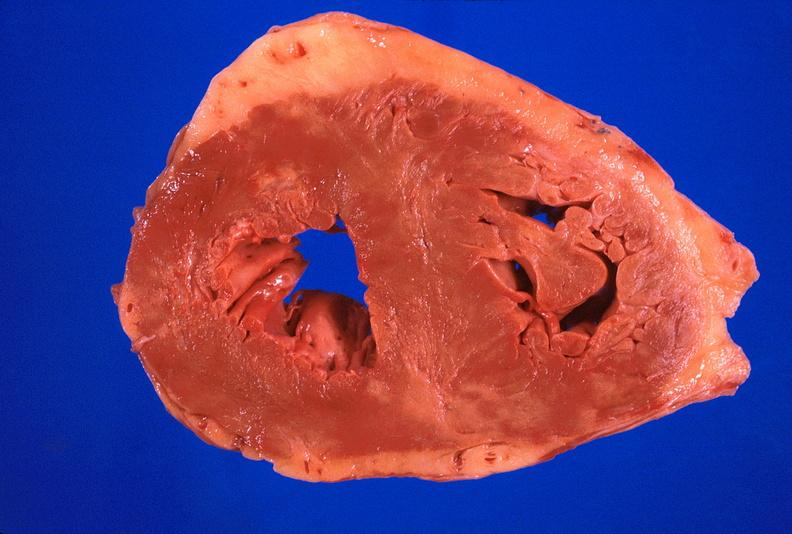where is this?
Answer the question using a single word or phrase. Heart 